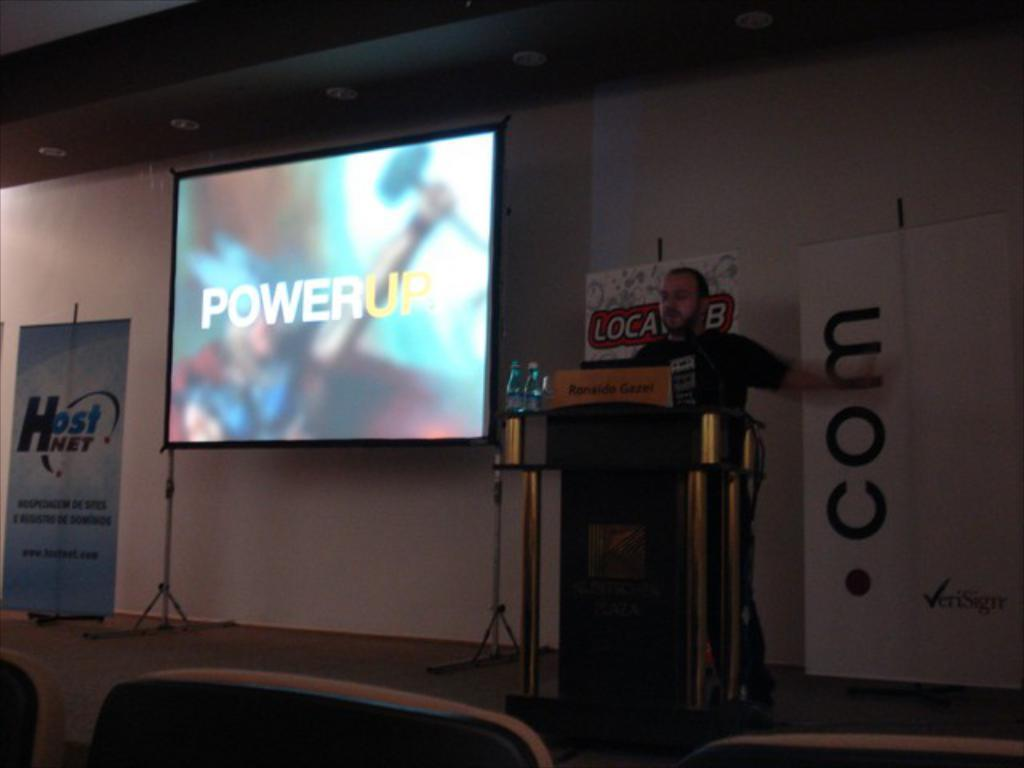<image>
Render a clear and concise summary of the photo. A screen is projected with an image that reads "power up." 